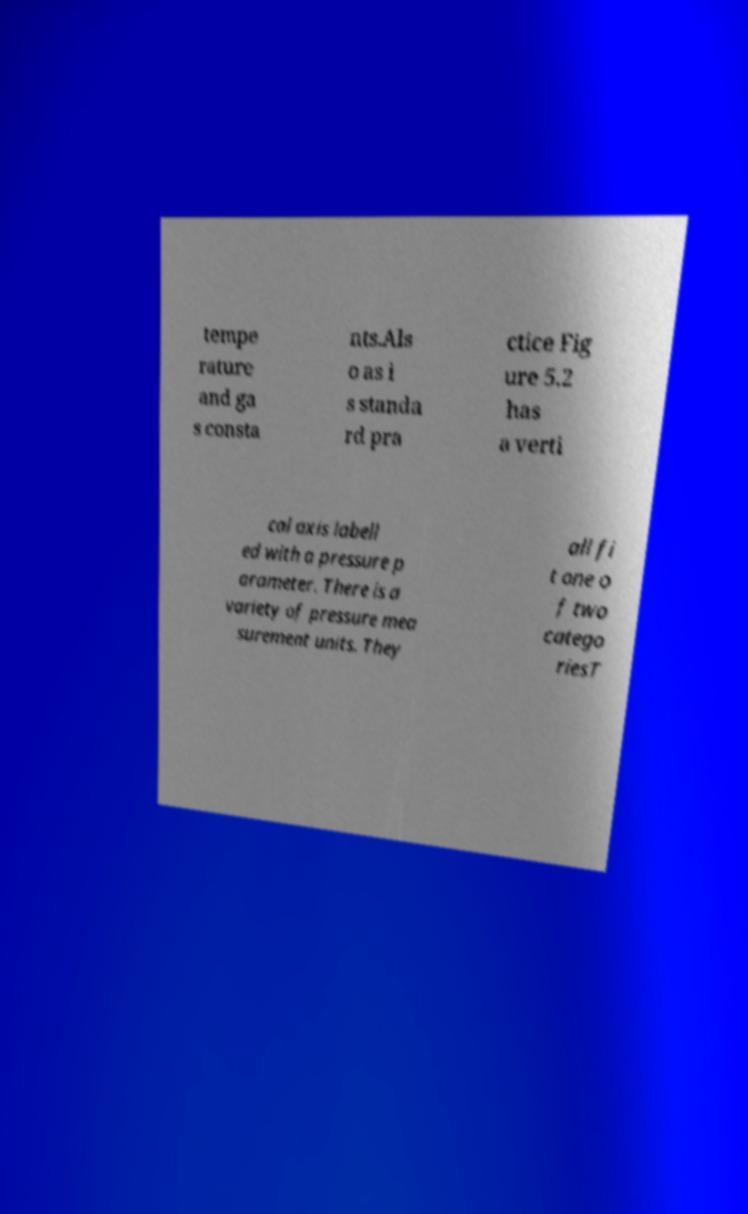What messages or text are displayed in this image? I need them in a readable, typed format. tempe rature and ga s consta nts.Als o as i s standa rd pra ctice Fig ure 5.2 has a verti cal axis labell ed with a pressure p arameter. There is a variety of pressure mea surement units. They all fi t one o f two catego riesT 